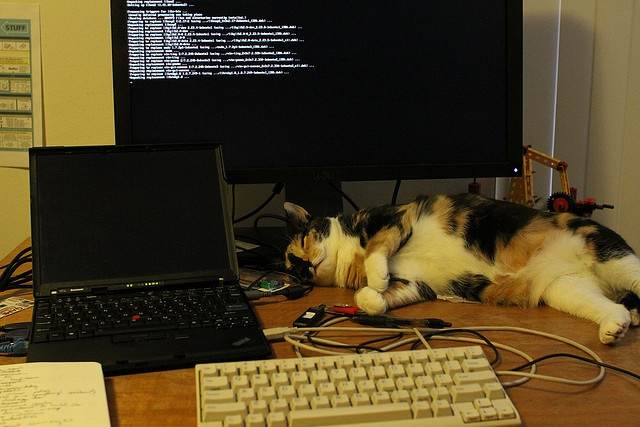Describe the objects in this image and their specific colors. I can see tv in tan, black, white, lightblue, and gray tones, laptop in tan, black, darkgreen, gray, and maroon tones, cat in tan, black, and olive tones, keyboard in tan and olive tones, and keyboard in tan, black, darkgreen, gray, and olive tones in this image. 